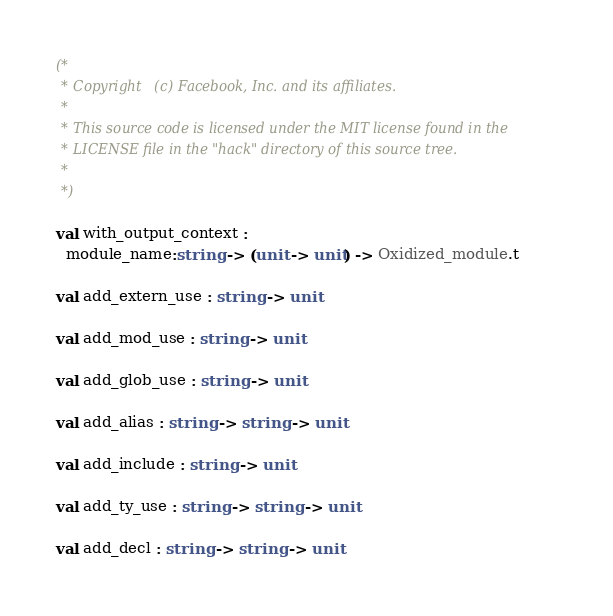<code> <loc_0><loc_0><loc_500><loc_500><_OCaml_>(*
 * Copyright (c) Facebook, Inc. and its affiliates.
 *
 * This source code is licensed under the MIT license found in the
 * LICENSE file in the "hack" directory of this source tree.
 *
 *)

val with_output_context :
  module_name:string -> (unit -> unit) -> Oxidized_module.t

val add_extern_use : string -> unit

val add_mod_use : string -> unit

val add_glob_use : string -> unit

val add_alias : string -> string -> unit

val add_include : string -> unit

val add_ty_use : string -> string -> unit

val add_decl : string -> string -> unit
</code> 